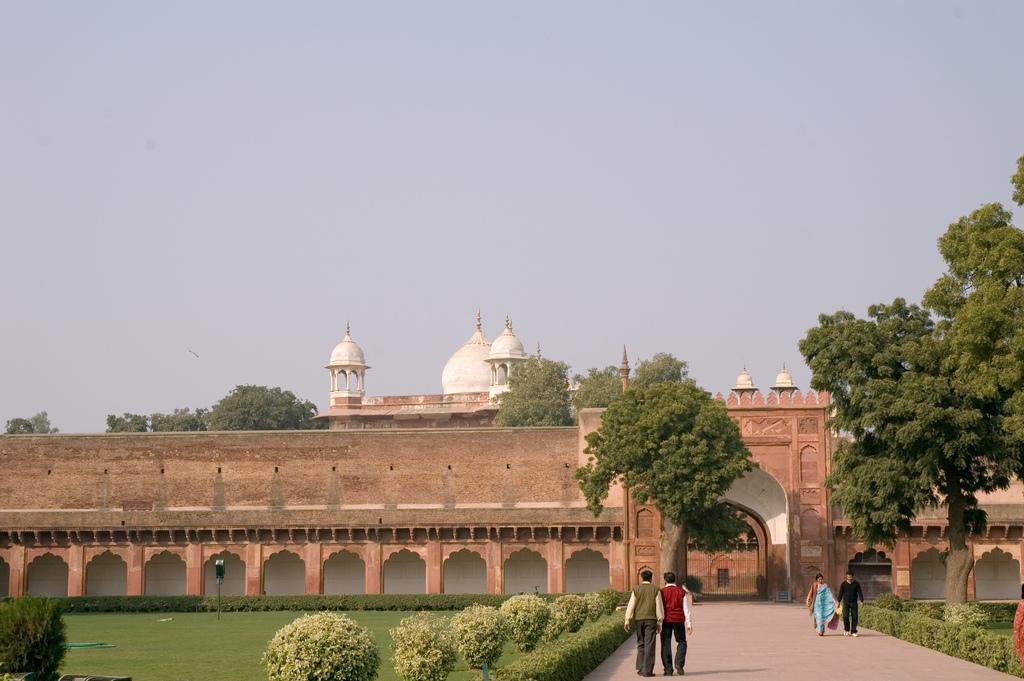Can you describe this image briefly? In this image we can see there is a monument in front of it there are people, a pole and a garden which contains trees and plants, in the background there are trees and there are clouds in the sky. 